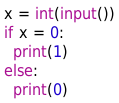<code> <loc_0><loc_0><loc_500><loc_500><_Python_>x = int(input())
if x = 0:
  print(1)
else:
  print(0)</code> 